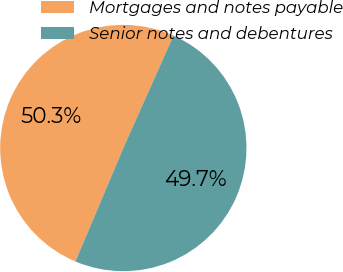Convert chart. <chart><loc_0><loc_0><loc_500><loc_500><pie_chart><fcel>Mortgages and notes payable<fcel>Senior notes and debentures<nl><fcel>50.32%<fcel>49.68%<nl></chart> 